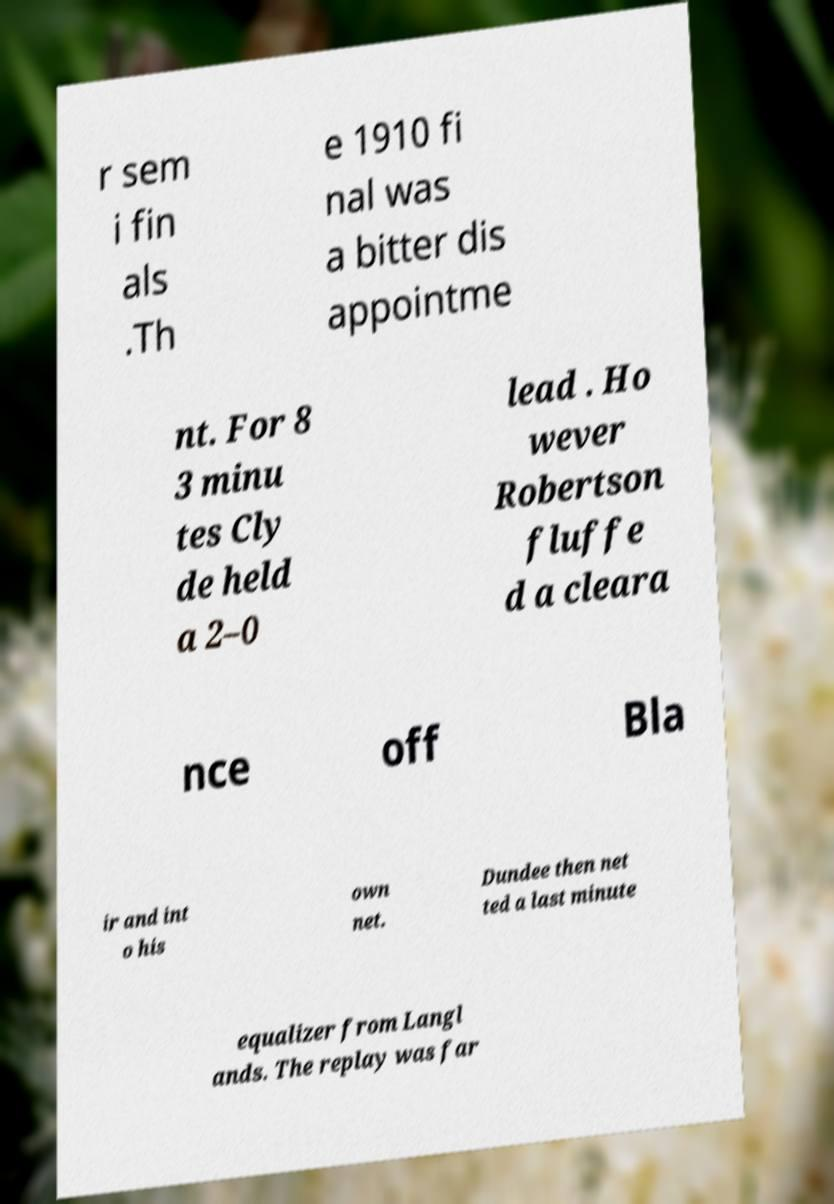What messages or text are displayed in this image? I need them in a readable, typed format. r sem i fin als .Th e 1910 fi nal was a bitter dis appointme nt. For 8 3 minu tes Cly de held a 2–0 lead . Ho wever Robertson fluffe d a cleara nce off Bla ir and int o his own net. Dundee then net ted a last minute equalizer from Langl ands. The replay was far 